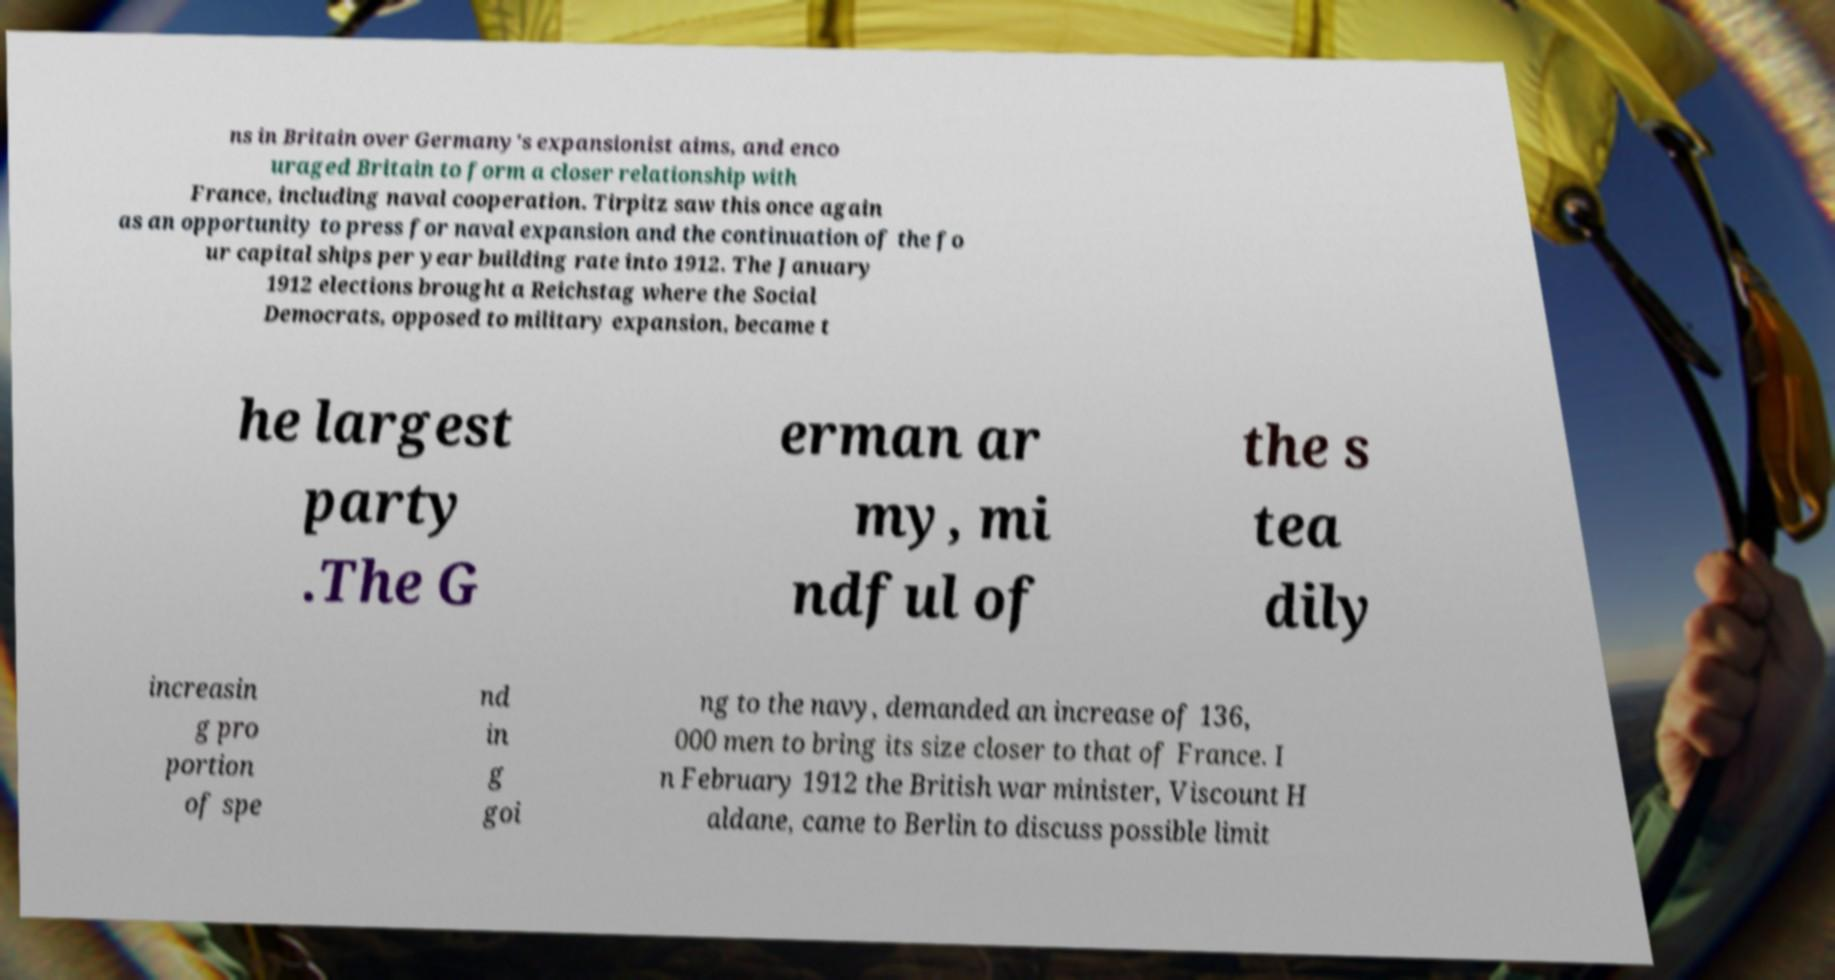Could you assist in decoding the text presented in this image and type it out clearly? ns in Britain over Germany's expansionist aims, and enco uraged Britain to form a closer relationship with France, including naval cooperation. Tirpitz saw this once again as an opportunity to press for naval expansion and the continuation of the fo ur capital ships per year building rate into 1912. The January 1912 elections brought a Reichstag where the Social Democrats, opposed to military expansion, became t he largest party .The G erman ar my, mi ndful of the s tea dily increasin g pro portion of spe nd in g goi ng to the navy, demanded an increase of 136, 000 men to bring its size closer to that of France. I n February 1912 the British war minister, Viscount H aldane, came to Berlin to discuss possible limit 